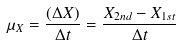<formula> <loc_0><loc_0><loc_500><loc_500>\mu _ { X } = \frac { ( \Delta X ) } { \Delta t } = \frac { X _ { 2 n d } - X _ { 1 s t } } { \Delta t }</formula> 